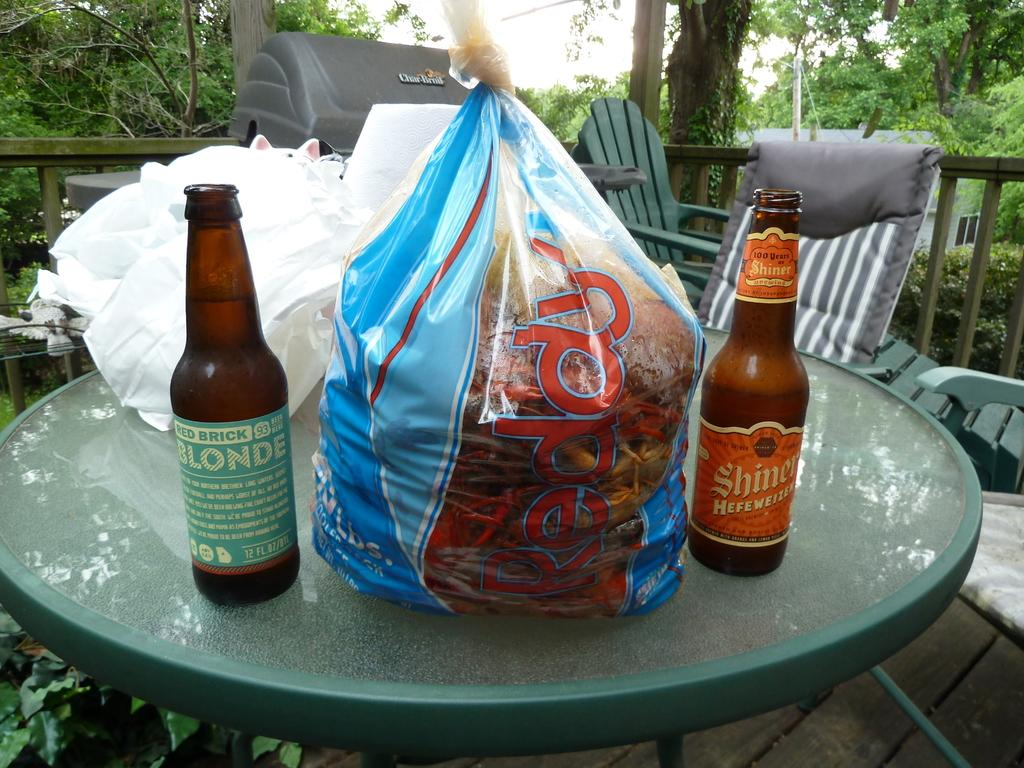What type of furniture is present in the image? There are chairs and a table in the image. What is placed on the table? There are bottles and carry bags on the table. What can be seen in the background of the image? There are trees in the background of the image. What type of tax is being discussed in the image? There is no discussion of tax in the image; it features chairs, a table, bottles, carry bags, and trees in the background. Can you see the brain of any person in the image? There is no brain visible in the image; it only contains chairs, a table, bottles, carry bags, and trees in the background. 